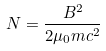<formula> <loc_0><loc_0><loc_500><loc_500>N = { \frac { B ^ { 2 } } { 2 \mu _ { 0 } m c ^ { 2 } } }</formula> 